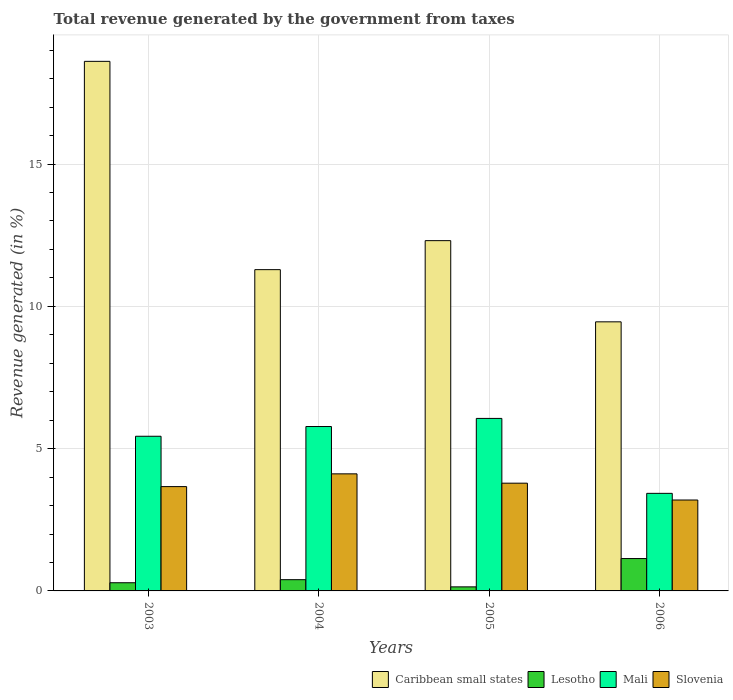How many different coloured bars are there?
Your answer should be compact. 4. How many groups of bars are there?
Your answer should be very brief. 4. Are the number of bars per tick equal to the number of legend labels?
Make the answer very short. Yes. Are the number of bars on each tick of the X-axis equal?
Your response must be concise. Yes. How many bars are there on the 1st tick from the left?
Ensure brevity in your answer.  4. In how many cases, is the number of bars for a given year not equal to the number of legend labels?
Provide a succinct answer. 0. What is the total revenue generated in Slovenia in 2006?
Your response must be concise. 3.19. Across all years, what is the maximum total revenue generated in Mali?
Your answer should be very brief. 6.06. Across all years, what is the minimum total revenue generated in Caribbean small states?
Keep it short and to the point. 9.46. In which year was the total revenue generated in Caribbean small states maximum?
Your answer should be compact. 2003. What is the total total revenue generated in Caribbean small states in the graph?
Give a very brief answer. 51.66. What is the difference between the total revenue generated in Lesotho in 2005 and that in 2006?
Make the answer very short. -0.99. What is the difference between the total revenue generated in Caribbean small states in 2003 and the total revenue generated in Lesotho in 2005?
Give a very brief answer. 18.47. What is the average total revenue generated in Slovenia per year?
Your response must be concise. 3.69. In the year 2004, what is the difference between the total revenue generated in Slovenia and total revenue generated in Lesotho?
Provide a short and direct response. 3.72. In how many years, is the total revenue generated in Lesotho greater than 13 %?
Give a very brief answer. 0. What is the ratio of the total revenue generated in Slovenia in 2003 to that in 2005?
Provide a succinct answer. 0.97. Is the total revenue generated in Caribbean small states in 2003 less than that in 2006?
Ensure brevity in your answer.  No. Is the difference between the total revenue generated in Slovenia in 2003 and 2006 greater than the difference between the total revenue generated in Lesotho in 2003 and 2006?
Offer a terse response. Yes. What is the difference between the highest and the second highest total revenue generated in Caribbean small states?
Your answer should be very brief. 6.3. What is the difference between the highest and the lowest total revenue generated in Slovenia?
Your response must be concise. 0.92. Is the sum of the total revenue generated in Caribbean small states in 2004 and 2006 greater than the maximum total revenue generated in Slovenia across all years?
Offer a very short reply. Yes. Is it the case that in every year, the sum of the total revenue generated in Lesotho and total revenue generated in Mali is greater than the sum of total revenue generated in Slovenia and total revenue generated in Caribbean small states?
Keep it short and to the point. Yes. What does the 2nd bar from the left in 2005 represents?
Offer a terse response. Lesotho. What does the 4th bar from the right in 2006 represents?
Give a very brief answer. Caribbean small states. How many years are there in the graph?
Your answer should be compact. 4. Does the graph contain any zero values?
Give a very brief answer. No. Does the graph contain grids?
Give a very brief answer. Yes. How many legend labels are there?
Make the answer very short. 4. What is the title of the graph?
Offer a very short reply. Total revenue generated by the government from taxes. What is the label or title of the X-axis?
Keep it short and to the point. Years. What is the label or title of the Y-axis?
Your response must be concise. Revenue generated (in %). What is the Revenue generated (in %) of Caribbean small states in 2003?
Your answer should be compact. 18.61. What is the Revenue generated (in %) in Lesotho in 2003?
Offer a very short reply. 0.29. What is the Revenue generated (in %) of Mali in 2003?
Ensure brevity in your answer.  5.44. What is the Revenue generated (in %) of Slovenia in 2003?
Provide a succinct answer. 3.67. What is the Revenue generated (in %) in Caribbean small states in 2004?
Offer a very short reply. 11.29. What is the Revenue generated (in %) of Lesotho in 2004?
Offer a terse response. 0.4. What is the Revenue generated (in %) of Mali in 2004?
Keep it short and to the point. 5.78. What is the Revenue generated (in %) in Slovenia in 2004?
Offer a terse response. 4.11. What is the Revenue generated (in %) of Caribbean small states in 2005?
Your answer should be compact. 12.31. What is the Revenue generated (in %) of Lesotho in 2005?
Offer a very short reply. 0.14. What is the Revenue generated (in %) of Mali in 2005?
Offer a terse response. 6.06. What is the Revenue generated (in %) of Slovenia in 2005?
Ensure brevity in your answer.  3.79. What is the Revenue generated (in %) in Caribbean small states in 2006?
Keep it short and to the point. 9.46. What is the Revenue generated (in %) in Lesotho in 2006?
Your answer should be very brief. 1.14. What is the Revenue generated (in %) of Mali in 2006?
Provide a short and direct response. 3.43. What is the Revenue generated (in %) of Slovenia in 2006?
Provide a short and direct response. 3.19. Across all years, what is the maximum Revenue generated (in %) in Caribbean small states?
Offer a terse response. 18.61. Across all years, what is the maximum Revenue generated (in %) in Lesotho?
Ensure brevity in your answer.  1.14. Across all years, what is the maximum Revenue generated (in %) in Mali?
Your answer should be compact. 6.06. Across all years, what is the maximum Revenue generated (in %) in Slovenia?
Provide a succinct answer. 4.11. Across all years, what is the minimum Revenue generated (in %) of Caribbean small states?
Give a very brief answer. 9.46. Across all years, what is the minimum Revenue generated (in %) in Lesotho?
Give a very brief answer. 0.14. Across all years, what is the minimum Revenue generated (in %) in Mali?
Keep it short and to the point. 3.43. Across all years, what is the minimum Revenue generated (in %) in Slovenia?
Offer a terse response. 3.19. What is the total Revenue generated (in %) in Caribbean small states in the graph?
Give a very brief answer. 51.66. What is the total Revenue generated (in %) in Lesotho in the graph?
Your answer should be compact. 1.96. What is the total Revenue generated (in %) of Mali in the graph?
Provide a succinct answer. 20.7. What is the total Revenue generated (in %) of Slovenia in the graph?
Provide a succinct answer. 14.76. What is the difference between the Revenue generated (in %) of Caribbean small states in 2003 and that in 2004?
Your answer should be compact. 7.32. What is the difference between the Revenue generated (in %) of Lesotho in 2003 and that in 2004?
Offer a very short reply. -0.11. What is the difference between the Revenue generated (in %) in Mali in 2003 and that in 2004?
Offer a terse response. -0.34. What is the difference between the Revenue generated (in %) in Slovenia in 2003 and that in 2004?
Keep it short and to the point. -0.45. What is the difference between the Revenue generated (in %) in Caribbean small states in 2003 and that in 2005?
Ensure brevity in your answer.  6.3. What is the difference between the Revenue generated (in %) in Lesotho in 2003 and that in 2005?
Ensure brevity in your answer.  0.14. What is the difference between the Revenue generated (in %) in Mali in 2003 and that in 2005?
Provide a succinct answer. -0.63. What is the difference between the Revenue generated (in %) in Slovenia in 2003 and that in 2005?
Offer a very short reply. -0.12. What is the difference between the Revenue generated (in %) in Caribbean small states in 2003 and that in 2006?
Offer a very short reply. 9.15. What is the difference between the Revenue generated (in %) in Lesotho in 2003 and that in 2006?
Provide a succinct answer. -0.85. What is the difference between the Revenue generated (in %) of Mali in 2003 and that in 2006?
Offer a very short reply. 2.01. What is the difference between the Revenue generated (in %) in Slovenia in 2003 and that in 2006?
Provide a short and direct response. 0.47. What is the difference between the Revenue generated (in %) in Caribbean small states in 2004 and that in 2005?
Make the answer very short. -1.02. What is the difference between the Revenue generated (in %) of Lesotho in 2004 and that in 2005?
Make the answer very short. 0.25. What is the difference between the Revenue generated (in %) in Mali in 2004 and that in 2005?
Offer a terse response. -0.28. What is the difference between the Revenue generated (in %) of Slovenia in 2004 and that in 2005?
Offer a very short reply. 0.33. What is the difference between the Revenue generated (in %) in Caribbean small states in 2004 and that in 2006?
Make the answer very short. 1.83. What is the difference between the Revenue generated (in %) of Lesotho in 2004 and that in 2006?
Your response must be concise. -0.74. What is the difference between the Revenue generated (in %) in Mali in 2004 and that in 2006?
Offer a very short reply. 2.35. What is the difference between the Revenue generated (in %) of Slovenia in 2004 and that in 2006?
Your response must be concise. 0.92. What is the difference between the Revenue generated (in %) of Caribbean small states in 2005 and that in 2006?
Give a very brief answer. 2.85. What is the difference between the Revenue generated (in %) in Lesotho in 2005 and that in 2006?
Provide a short and direct response. -0.99. What is the difference between the Revenue generated (in %) in Mali in 2005 and that in 2006?
Offer a terse response. 2.63. What is the difference between the Revenue generated (in %) of Slovenia in 2005 and that in 2006?
Give a very brief answer. 0.59. What is the difference between the Revenue generated (in %) of Caribbean small states in 2003 and the Revenue generated (in %) of Lesotho in 2004?
Provide a succinct answer. 18.21. What is the difference between the Revenue generated (in %) in Caribbean small states in 2003 and the Revenue generated (in %) in Mali in 2004?
Keep it short and to the point. 12.83. What is the difference between the Revenue generated (in %) of Caribbean small states in 2003 and the Revenue generated (in %) of Slovenia in 2004?
Offer a very short reply. 14.5. What is the difference between the Revenue generated (in %) in Lesotho in 2003 and the Revenue generated (in %) in Mali in 2004?
Offer a very short reply. -5.49. What is the difference between the Revenue generated (in %) of Lesotho in 2003 and the Revenue generated (in %) of Slovenia in 2004?
Provide a succinct answer. -3.83. What is the difference between the Revenue generated (in %) in Mali in 2003 and the Revenue generated (in %) in Slovenia in 2004?
Make the answer very short. 1.32. What is the difference between the Revenue generated (in %) in Caribbean small states in 2003 and the Revenue generated (in %) in Lesotho in 2005?
Ensure brevity in your answer.  18.47. What is the difference between the Revenue generated (in %) in Caribbean small states in 2003 and the Revenue generated (in %) in Mali in 2005?
Offer a very short reply. 12.55. What is the difference between the Revenue generated (in %) of Caribbean small states in 2003 and the Revenue generated (in %) of Slovenia in 2005?
Your response must be concise. 14.82. What is the difference between the Revenue generated (in %) of Lesotho in 2003 and the Revenue generated (in %) of Mali in 2005?
Your answer should be very brief. -5.77. What is the difference between the Revenue generated (in %) in Lesotho in 2003 and the Revenue generated (in %) in Slovenia in 2005?
Provide a succinct answer. -3.5. What is the difference between the Revenue generated (in %) of Mali in 2003 and the Revenue generated (in %) of Slovenia in 2005?
Make the answer very short. 1.65. What is the difference between the Revenue generated (in %) of Caribbean small states in 2003 and the Revenue generated (in %) of Lesotho in 2006?
Offer a terse response. 17.47. What is the difference between the Revenue generated (in %) of Caribbean small states in 2003 and the Revenue generated (in %) of Mali in 2006?
Make the answer very short. 15.18. What is the difference between the Revenue generated (in %) in Caribbean small states in 2003 and the Revenue generated (in %) in Slovenia in 2006?
Provide a succinct answer. 15.41. What is the difference between the Revenue generated (in %) of Lesotho in 2003 and the Revenue generated (in %) of Mali in 2006?
Offer a very short reply. -3.14. What is the difference between the Revenue generated (in %) of Lesotho in 2003 and the Revenue generated (in %) of Slovenia in 2006?
Ensure brevity in your answer.  -2.91. What is the difference between the Revenue generated (in %) of Mali in 2003 and the Revenue generated (in %) of Slovenia in 2006?
Ensure brevity in your answer.  2.24. What is the difference between the Revenue generated (in %) of Caribbean small states in 2004 and the Revenue generated (in %) of Lesotho in 2005?
Your answer should be very brief. 11.15. What is the difference between the Revenue generated (in %) in Caribbean small states in 2004 and the Revenue generated (in %) in Mali in 2005?
Keep it short and to the point. 5.23. What is the difference between the Revenue generated (in %) of Caribbean small states in 2004 and the Revenue generated (in %) of Slovenia in 2005?
Ensure brevity in your answer.  7.5. What is the difference between the Revenue generated (in %) of Lesotho in 2004 and the Revenue generated (in %) of Mali in 2005?
Your answer should be very brief. -5.67. What is the difference between the Revenue generated (in %) in Lesotho in 2004 and the Revenue generated (in %) in Slovenia in 2005?
Give a very brief answer. -3.39. What is the difference between the Revenue generated (in %) of Mali in 2004 and the Revenue generated (in %) of Slovenia in 2005?
Ensure brevity in your answer.  1.99. What is the difference between the Revenue generated (in %) in Caribbean small states in 2004 and the Revenue generated (in %) in Lesotho in 2006?
Provide a short and direct response. 10.15. What is the difference between the Revenue generated (in %) in Caribbean small states in 2004 and the Revenue generated (in %) in Mali in 2006?
Your answer should be very brief. 7.86. What is the difference between the Revenue generated (in %) in Caribbean small states in 2004 and the Revenue generated (in %) in Slovenia in 2006?
Provide a short and direct response. 8.1. What is the difference between the Revenue generated (in %) of Lesotho in 2004 and the Revenue generated (in %) of Mali in 2006?
Make the answer very short. -3.03. What is the difference between the Revenue generated (in %) of Lesotho in 2004 and the Revenue generated (in %) of Slovenia in 2006?
Your response must be concise. -2.8. What is the difference between the Revenue generated (in %) in Mali in 2004 and the Revenue generated (in %) in Slovenia in 2006?
Keep it short and to the point. 2.58. What is the difference between the Revenue generated (in %) of Caribbean small states in 2005 and the Revenue generated (in %) of Lesotho in 2006?
Keep it short and to the point. 11.17. What is the difference between the Revenue generated (in %) of Caribbean small states in 2005 and the Revenue generated (in %) of Mali in 2006?
Your answer should be compact. 8.88. What is the difference between the Revenue generated (in %) of Caribbean small states in 2005 and the Revenue generated (in %) of Slovenia in 2006?
Your answer should be very brief. 9.11. What is the difference between the Revenue generated (in %) of Lesotho in 2005 and the Revenue generated (in %) of Mali in 2006?
Provide a succinct answer. -3.29. What is the difference between the Revenue generated (in %) in Lesotho in 2005 and the Revenue generated (in %) in Slovenia in 2006?
Give a very brief answer. -3.05. What is the difference between the Revenue generated (in %) in Mali in 2005 and the Revenue generated (in %) in Slovenia in 2006?
Offer a terse response. 2.87. What is the average Revenue generated (in %) in Caribbean small states per year?
Keep it short and to the point. 12.92. What is the average Revenue generated (in %) in Lesotho per year?
Your response must be concise. 0.49. What is the average Revenue generated (in %) of Mali per year?
Offer a very short reply. 5.18. What is the average Revenue generated (in %) in Slovenia per year?
Your answer should be very brief. 3.69. In the year 2003, what is the difference between the Revenue generated (in %) of Caribbean small states and Revenue generated (in %) of Lesotho?
Make the answer very short. 18.32. In the year 2003, what is the difference between the Revenue generated (in %) in Caribbean small states and Revenue generated (in %) in Mali?
Your response must be concise. 13.17. In the year 2003, what is the difference between the Revenue generated (in %) of Caribbean small states and Revenue generated (in %) of Slovenia?
Keep it short and to the point. 14.94. In the year 2003, what is the difference between the Revenue generated (in %) of Lesotho and Revenue generated (in %) of Mali?
Your answer should be very brief. -5.15. In the year 2003, what is the difference between the Revenue generated (in %) of Lesotho and Revenue generated (in %) of Slovenia?
Provide a short and direct response. -3.38. In the year 2003, what is the difference between the Revenue generated (in %) of Mali and Revenue generated (in %) of Slovenia?
Provide a succinct answer. 1.77. In the year 2004, what is the difference between the Revenue generated (in %) of Caribbean small states and Revenue generated (in %) of Lesotho?
Your response must be concise. 10.89. In the year 2004, what is the difference between the Revenue generated (in %) in Caribbean small states and Revenue generated (in %) in Mali?
Your answer should be very brief. 5.51. In the year 2004, what is the difference between the Revenue generated (in %) in Caribbean small states and Revenue generated (in %) in Slovenia?
Make the answer very short. 7.18. In the year 2004, what is the difference between the Revenue generated (in %) of Lesotho and Revenue generated (in %) of Mali?
Provide a short and direct response. -5.38. In the year 2004, what is the difference between the Revenue generated (in %) of Lesotho and Revenue generated (in %) of Slovenia?
Ensure brevity in your answer.  -3.72. In the year 2004, what is the difference between the Revenue generated (in %) in Mali and Revenue generated (in %) in Slovenia?
Provide a succinct answer. 1.66. In the year 2005, what is the difference between the Revenue generated (in %) of Caribbean small states and Revenue generated (in %) of Lesotho?
Give a very brief answer. 12.17. In the year 2005, what is the difference between the Revenue generated (in %) of Caribbean small states and Revenue generated (in %) of Mali?
Your answer should be compact. 6.25. In the year 2005, what is the difference between the Revenue generated (in %) of Caribbean small states and Revenue generated (in %) of Slovenia?
Keep it short and to the point. 8.52. In the year 2005, what is the difference between the Revenue generated (in %) in Lesotho and Revenue generated (in %) in Mali?
Make the answer very short. -5.92. In the year 2005, what is the difference between the Revenue generated (in %) of Lesotho and Revenue generated (in %) of Slovenia?
Provide a succinct answer. -3.64. In the year 2005, what is the difference between the Revenue generated (in %) of Mali and Revenue generated (in %) of Slovenia?
Your response must be concise. 2.28. In the year 2006, what is the difference between the Revenue generated (in %) of Caribbean small states and Revenue generated (in %) of Lesotho?
Provide a succinct answer. 8.32. In the year 2006, what is the difference between the Revenue generated (in %) of Caribbean small states and Revenue generated (in %) of Mali?
Make the answer very short. 6.03. In the year 2006, what is the difference between the Revenue generated (in %) in Caribbean small states and Revenue generated (in %) in Slovenia?
Offer a terse response. 6.26. In the year 2006, what is the difference between the Revenue generated (in %) in Lesotho and Revenue generated (in %) in Mali?
Keep it short and to the point. -2.29. In the year 2006, what is the difference between the Revenue generated (in %) in Lesotho and Revenue generated (in %) in Slovenia?
Provide a succinct answer. -2.06. In the year 2006, what is the difference between the Revenue generated (in %) of Mali and Revenue generated (in %) of Slovenia?
Offer a very short reply. 0.23. What is the ratio of the Revenue generated (in %) in Caribbean small states in 2003 to that in 2004?
Provide a succinct answer. 1.65. What is the ratio of the Revenue generated (in %) of Lesotho in 2003 to that in 2004?
Ensure brevity in your answer.  0.73. What is the ratio of the Revenue generated (in %) of Mali in 2003 to that in 2004?
Make the answer very short. 0.94. What is the ratio of the Revenue generated (in %) of Slovenia in 2003 to that in 2004?
Your answer should be very brief. 0.89. What is the ratio of the Revenue generated (in %) in Caribbean small states in 2003 to that in 2005?
Provide a short and direct response. 1.51. What is the ratio of the Revenue generated (in %) in Lesotho in 2003 to that in 2005?
Your response must be concise. 2.01. What is the ratio of the Revenue generated (in %) of Mali in 2003 to that in 2005?
Offer a very short reply. 0.9. What is the ratio of the Revenue generated (in %) in Slovenia in 2003 to that in 2005?
Make the answer very short. 0.97. What is the ratio of the Revenue generated (in %) in Caribbean small states in 2003 to that in 2006?
Provide a short and direct response. 1.97. What is the ratio of the Revenue generated (in %) of Lesotho in 2003 to that in 2006?
Make the answer very short. 0.25. What is the ratio of the Revenue generated (in %) in Mali in 2003 to that in 2006?
Your answer should be very brief. 1.59. What is the ratio of the Revenue generated (in %) of Slovenia in 2003 to that in 2006?
Your answer should be compact. 1.15. What is the ratio of the Revenue generated (in %) of Caribbean small states in 2004 to that in 2005?
Make the answer very short. 0.92. What is the ratio of the Revenue generated (in %) of Lesotho in 2004 to that in 2005?
Make the answer very short. 2.77. What is the ratio of the Revenue generated (in %) of Mali in 2004 to that in 2005?
Your answer should be compact. 0.95. What is the ratio of the Revenue generated (in %) of Slovenia in 2004 to that in 2005?
Offer a terse response. 1.09. What is the ratio of the Revenue generated (in %) in Caribbean small states in 2004 to that in 2006?
Your answer should be very brief. 1.19. What is the ratio of the Revenue generated (in %) of Lesotho in 2004 to that in 2006?
Offer a very short reply. 0.35. What is the ratio of the Revenue generated (in %) in Mali in 2004 to that in 2006?
Offer a terse response. 1.69. What is the ratio of the Revenue generated (in %) of Slovenia in 2004 to that in 2006?
Ensure brevity in your answer.  1.29. What is the ratio of the Revenue generated (in %) in Caribbean small states in 2005 to that in 2006?
Give a very brief answer. 1.3. What is the ratio of the Revenue generated (in %) of Lesotho in 2005 to that in 2006?
Give a very brief answer. 0.13. What is the ratio of the Revenue generated (in %) in Mali in 2005 to that in 2006?
Offer a terse response. 1.77. What is the ratio of the Revenue generated (in %) in Slovenia in 2005 to that in 2006?
Offer a terse response. 1.19. What is the difference between the highest and the second highest Revenue generated (in %) of Caribbean small states?
Your answer should be very brief. 6.3. What is the difference between the highest and the second highest Revenue generated (in %) in Lesotho?
Keep it short and to the point. 0.74. What is the difference between the highest and the second highest Revenue generated (in %) of Mali?
Your answer should be compact. 0.28. What is the difference between the highest and the second highest Revenue generated (in %) of Slovenia?
Your answer should be compact. 0.33. What is the difference between the highest and the lowest Revenue generated (in %) in Caribbean small states?
Offer a very short reply. 9.15. What is the difference between the highest and the lowest Revenue generated (in %) of Mali?
Give a very brief answer. 2.63. What is the difference between the highest and the lowest Revenue generated (in %) of Slovenia?
Ensure brevity in your answer.  0.92. 